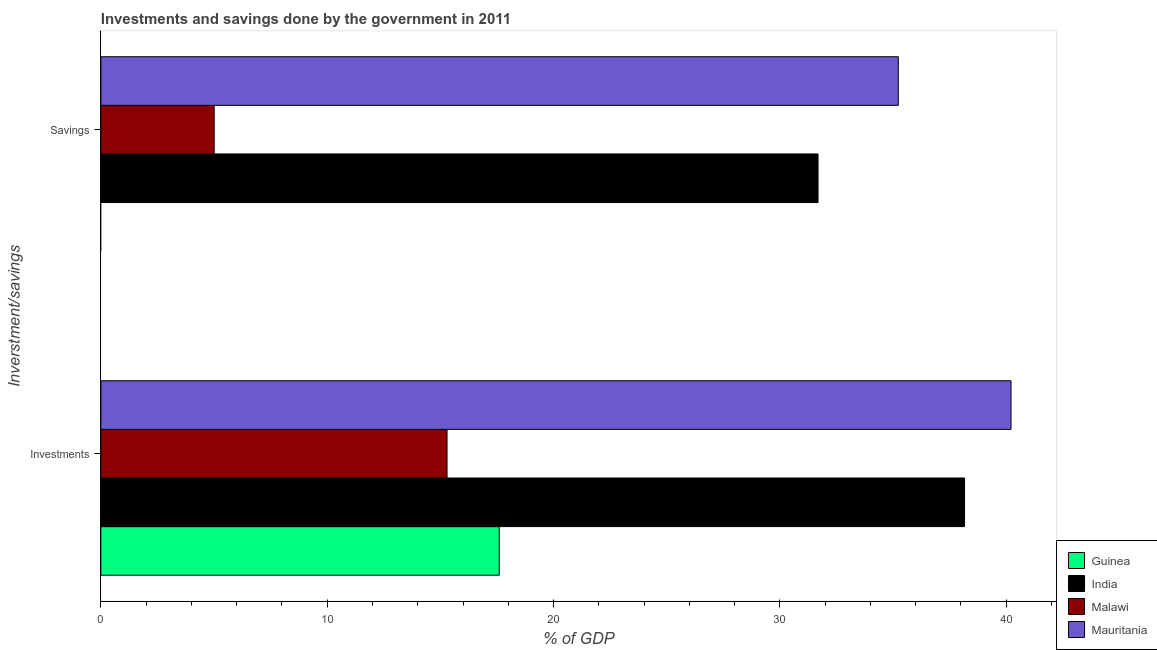Are the number of bars per tick equal to the number of legend labels?
Your response must be concise. No. Are the number of bars on each tick of the Y-axis equal?
Ensure brevity in your answer.  No. How many bars are there on the 1st tick from the bottom?
Your response must be concise. 4. What is the label of the 1st group of bars from the top?
Your answer should be very brief. Savings. Across all countries, what is the maximum investments of government?
Offer a very short reply. 40.21. In which country was the savings of government maximum?
Provide a succinct answer. Mauritania. What is the total investments of government in the graph?
Your answer should be compact. 111.26. What is the difference between the savings of government in Mauritania and that in Malawi?
Ensure brevity in your answer.  30.22. What is the difference between the savings of government in India and the investments of government in Malawi?
Make the answer very short. 16.39. What is the average investments of government per country?
Offer a very short reply. 27.82. What is the difference between the investments of government and savings of government in India?
Provide a succinct answer. 6.47. What is the ratio of the investments of government in Mauritania to that in Malawi?
Ensure brevity in your answer.  2.63. In how many countries, is the savings of government greater than the average savings of government taken over all countries?
Offer a very short reply. 2. How many bars are there?
Offer a terse response. 7. Are all the bars in the graph horizontal?
Make the answer very short. Yes. Where does the legend appear in the graph?
Your answer should be compact. Bottom right. How many legend labels are there?
Offer a very short reply. 4. How are the legend labels stacked?
Provide a succinct answer. Vertical. What is the title of the graph?
Provide a short and direct response. Investments and savings done by the government in 2011. What is the label or title of the X-axis?
Your response must be concise. % of GDP. What is the label or title of the Y-axis?
Keep it short and to the point. Inverstment/savings. What is the % of GDP of Guinea in Investments?
Keep it short and to the point. 17.6. What is the % of GDP in India in Investments?
Offer a terse response. 38.16. What is the % of GDP in Malawi in Investments?
Provide a succinct answer. 15.29. What is the % of GDP in Mauritania in Investments?
Offer a very short reply. 40.21. What is the % of GDP in India in Savings?
Your answer should be very brief. 31.69. What is the % of GDP in Malawi in Savings?
Keep it short and to the point. 5.01. What is the % of GDP of Mauritania in Savings?
Offer a terse response. 35.23. Across all Inverstment/savings, what is the maximum % of GDP in Guinea?
Make the answer very short. 17.6. Across all Inverstment/savings, what is the maximum % of GDP of India?
Provide a succinct answer. 38.16. Across all Inverstment/savings, what is the maximum % of GDP of Malawi?
Keep it short and to the point. 15.29. Across all Inverstment/savings, what is the maximum % of GDP of Mauritania?
Provide a succinct answer. 40.21. Across all Inverstment/savings, what is the minimum % of GDP in Guinea?
Your answer should be very brief. 0. Across all Inverstment/savings, what is the minimum % of GDP in India?
Keep it short and to the point. 31.69. Across all Inverstment/savings, what is the minimum % of GDP of Malawi?
Offer a very short reply. 5.01. Across all Inverstment/savings, what is the minimum % of GDP of Mauritania?
Your answer should be compact. 35.23. What is the total % of GDP of Guinea in the graph?
Offer a terse response. 17.6. What is the total % of GDP of India in the graph?
Give a very brief answer. 69.84. What is the total % of GDP in Malawi in the graph?
Ensure brevity in your answer.  20.3. What is the total % of GDP in Mauritania in the graph?
Provide a short and direct response. 75.44. What is the difference between the % of GDP in India in Investments and that in Savings?
Ensure brevity in your answer.  6.47. What is the difference between the % of GDP of Malawi in Investments and that in Savings?
Ensure brevity in your answer.  10.29. What is the difference between the % of GDP in Mauritania in Investments and that in Savings?
Offer a terse response. 4.98. What is the difference between the % of GDP in Guinea in Investments and the % of GDP in India in Savings?
Ensure brevity in your answer.  -14.09. What is the difference between the % of GDP of Guinea in Investments and the % of GDP of Malawi in Savings?
Keep it short and to the point. 12.59. What is the difference between the % of GDP of Guinea in Investments and the % of GDP of Mauritania in Savings?
Offer a terse response. -17.63. What is the difference between the % of GDP in India in Investments and the % of GDP in Malawi in Savings?
Give a very brief answer. 33.15. What is the difference between the % of GDP in India in Investments and the % of GDP in Mauritania in Savings?
Give a very brief answer. 2.93. What is the difference between the % of GDP of Malawi in Investments and the % of GDP of Mauritania in Savings?
Keep it short and to the point. -19.94. What is the average % of GDP in Guinea per Inverstment/savings?
Offer a very short reply. 8.8. What is the average % of GDP in India per Inverstment/savings?
Your answer should be very brief. 34.92. What is the average % of GDP of Malawi per Inverstment/savings?
Provide a succinct answer. 10.15. What is the average % of GDP in Mauritania per Inverstment/savings?
Make the answer very short. 37.72. What is the difference between the % of GDP of Guinea and % of GDP of India in Investments?
Your answer should be very brief. -20.56. What is the difference between the % of GDP in Guinea and % of GDP in Malawi in Investments?
Provide a short and direct response. 2.31. What is the difference between the % of GDP in Guinea and % of GDP in Mauritania in Investments?
Your answer should be compact. -22.61. What is the difference between the % of GDP of India and % of GDP of Malawi in Investments?
Your answer should be very brief. 22.86. What is the difference between the % of GDP of India and % of GDP of Mauritania in Investments?
Your answer should be very brief. -2.05. What is the difference between the % of GDP of Malawi and % of GDP of Mauritania in Investments?
Give a very brief answer. -24.92. What is the difference between the % of GDP of India and % of GDP of Malawi in Savings?
Your answer should be very brief. 26.68. What is the difference between the % of GDP of India and % of GDP of Mauritania in Savings?
Your answer should be very brief. -3.55. What is the difference between the % of GDP of Malawi and % of GDP of Mauritania in Savings?
Offer a terse response. -30.22. What is the ratio of the % of GDP of India in Investments to that in Savings?
Provide a short and direct response. 1.2. What is the ratio of the % of GDP in Malawi in Investments to that in Savings?
Offer a very short reply. 3.05. What is the ratio of the % of GDP in Mauritania in Investments to that in Savings?
Make the answer very short. 1.14. What is the difference between the highest and the second highest % of GDP in India?
Offer a very short reply. 6.47. What is the difference between the highest and the second highest % of GDP in Malawi?
Your answer should be compact. 10.29. What is the difference between the highest and the second highest % of GDP of Mauritania?
Provide a succinct answer. 4.98. What is the difference between the highest and the lowest % of GDP in Guinea?
Your answer should be compact. 17.6. What is the difference between the highest and the lowest % of GDP in India?
Your answer should be compact. 6.47. What is the difference between the highest and the lowest % of GDP of Malawi?
Offer a terse response. 10.29. What is the difference between the highest and the lowest % of GDP in Mauritania?
Offer a terse response. 4.98. 